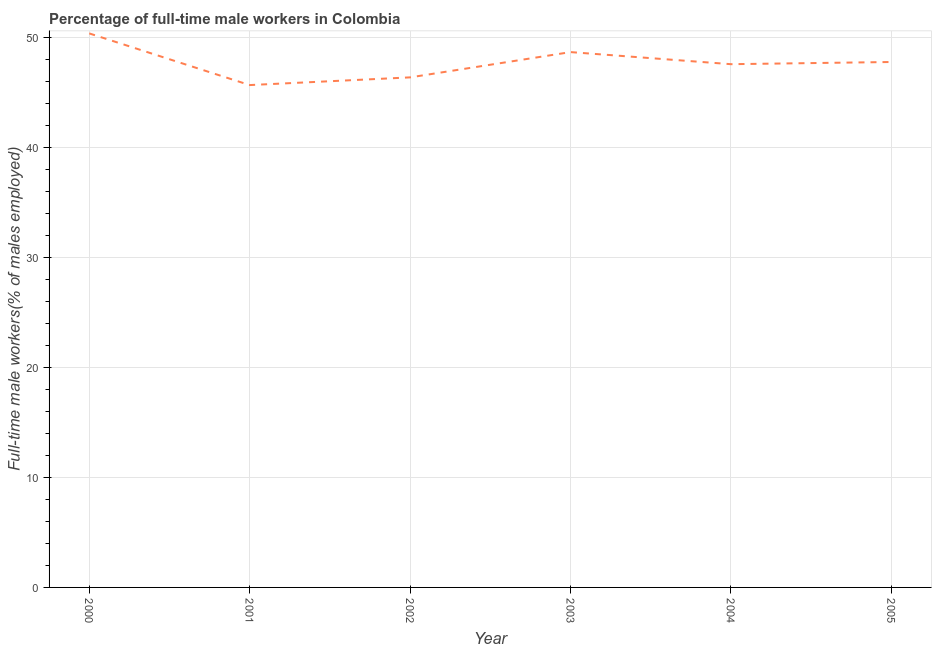What is the percentage of full-time male workers in 2002?
Make the answer very short. 46.4. Across all years, what is the maximum percentage of full-time male workers?
Ensure brevity in your answer.  50.4. Across all years, what is the minimum percentage of full-time male workers?
Provide a short and direct response. 45.7. In which year was the percentage of full-time male workers maximum?
Your answer should be compact. 2000. In which year was the percentage of full-time male workers minimum?
Provide a succinct answer. 2001. What is the sum of the percentage of full-time male workers?
Give a very brief answer. 286.6. What is the difference between the percentage of full-time male workers in 2002 and 2003?
Keep it short and to the point. -2.3. What is the average percentage of full-time male workers per year?
Provide a succinct answer. 47.77. What is the median percentage of full-time male workers?
Make the answer very short. 47.7. In how many years, is the percentage of full-time male workers greater than 28 %?
Provide a short and direct response. 6. What is the ratio of the percentage of full-time male workers in 2002 to that in 2003?
Ensure brevity in your answer.  0.95. What is the difference between the highest and the second highest percentage of full-time male workers?
Give a very brief answer. 1.7. What is the difference between the highest and the lowest percentage of full-time male workers?
Make the answer very short. 4.7. In how many years, is the percentage of full-time male workers greater than the average percentage of full-time male workers taken over all years?
Make the answer very short. 3. How many years are there in the graph?
Offer a terse response. 6. What is the difference between two consecutive major ticks on the Y-axis?
Give a very brief answer. 10. Are the values on the major ticks of Y-axis written in scientific E-notation?
Offer a terse response. No. Does the graph contain any zero values?
Your answer should be compact. No. What is the title of the graph?
Provide a short and direct response. Percentage of full-time male workers in Colombia. What is the label or title of the Y-axis?
Give a very brief answer. Full-time male workers(% of males employed). What is the Full-time male workers(% of males employed) of 2000?
Offer a very short reply. 50.4. What is the Full-time male workers(% of males employed) in 2001?
Provide a short and direct response. 45.7. What is the Full-time male workers(% of males employed) in 2002?
Provide a succinct answer. 46.4. What is the Full-time male workers(% of males employed) in 2003?
Offer a terse response. 48.7. What is the Full-time male workers(% of males employed) of 2004?
Your answer should be compact. 47.6. What is the Full-time male workers(% of males employed) of 2005?
Provide a succinct answer. 47.8. What is the difference between the Full-time male workers(% of males employed) in 2000 and 2002?
Your answer should be compact. 4. What is the difference between the Full-time male workers(% of males employed) in 2000 and 2003?
Ensure brevity in your answer.  1.7. What is the difference between the Full-time male workers(% of males employed) in 2000 and 2004?
Your answer should be compact. 2.8. What is the difference between the Full-time male workers(% of males employed) in 2000 and 2005?
Your answer should be compact. 2.6. What is the difference between the Full-time male workers(% of males employed) in 2002 and 2003?
Provide a succinct answer. -2.3. What is the difference between the Full-time male workers(% of males employed) in 2003 and 2005?
Your answer should be very brief. 0.9. What is the difference between the Full-time male workers(% of males employed) in 2004 and 2005?
Give a very brief answer. -0.2. What is the ratio of the Full-time male workers(% of males employed) in 2000 to that in 2001?
Offer a terse response. 1.1. What is the ratio of the Full-time male workers(% of males employed) in 2000 to that in 2002?
Make the answer very short. 1.09. What is the ratio of the Full-time male workers(% of males employed) in 2000 to that in 2003?
Your response must be concise. 1.03. What is the ratio of the Full-time male workers(% of males employed) in 2000 to that in 2004?
Your answer should be compact. 1.06. What is the ratio of the Full-time male workers(% of males employed) in 2000 to that in 2005?
Your response must be concise. 1.05. What is the ratio of the Full-time male workers(% of males employed) in 2001 to that in 2003?
Provide a short and direct response. 0.94. What is the ratio of the Full-time male workers(% of males employed) in 2001 to that in 2005?
Provide a succinct answer. 0.96. What is the ratio of the Full-time male workers(% of males employed) in 2002 to that in 2003?
Your answer should be compact. 0.95. What is the ratio of the Full-time male workers(% of males employed) in 2002 to that in 2004?
Keep it short and to the point. 0.97. What is the ratio of the Full-time male workers(% of males employed) in 2004 to that in 2005?
Offer a terse response. 1. 